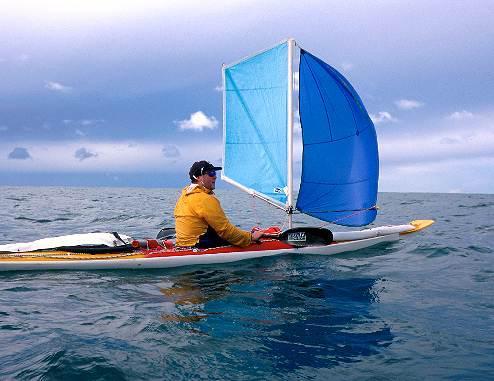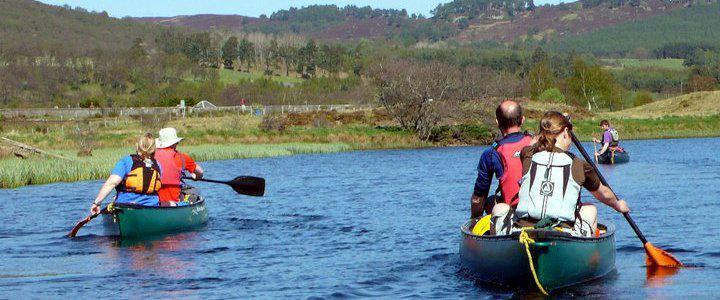The first image is the image on the left, the second image is the image on the right. Assess this claim about the two images: "There are people using red paddles.". Correct or not? Answer yes or no. No. The first image is the image on the left, the second image is the image on the right. Considering the images on both sides, is "Multiple canoes are headed away from the camera in one image." valid? Answer yes or no. Yes. 